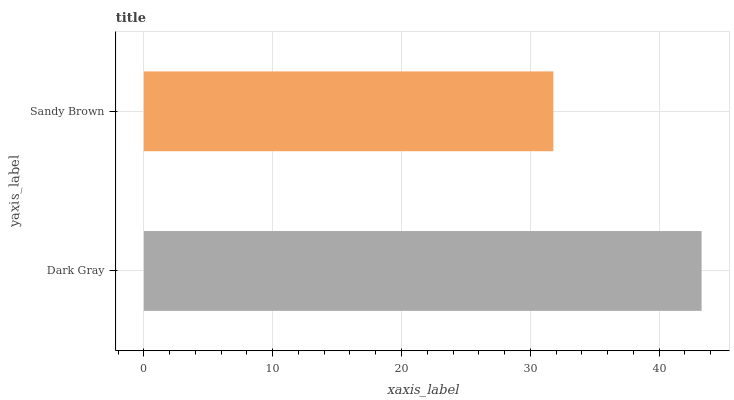Is Sandy Brown the minimum?
Answer yes or no. Yes. Is Dark Gray the maximum?
Answer yes or no. Yes. Is Sandy Brown the maximum?
Answer yes or no. No. Is Dark Gray greater than Sandy Brown?
Answer yes or no. Yes. Is Sandy Brown less than Dark Gray?
Answer yes or no. Yes. Is Sandy Brown greater than Dark Gray?
Answer yes or no. No. Is Dark Gray less than Sandy Brown?
Answer yes or no. No. Is Dark Gray the high median?
Answer yes or no. Yes. Is Sandy Brown the low median?
Answer yes or no. Yes. Is Sandy Brown the high median?
Answer yes or no. No. Is Dark Gray the low median?
Answer yes or no. No. 